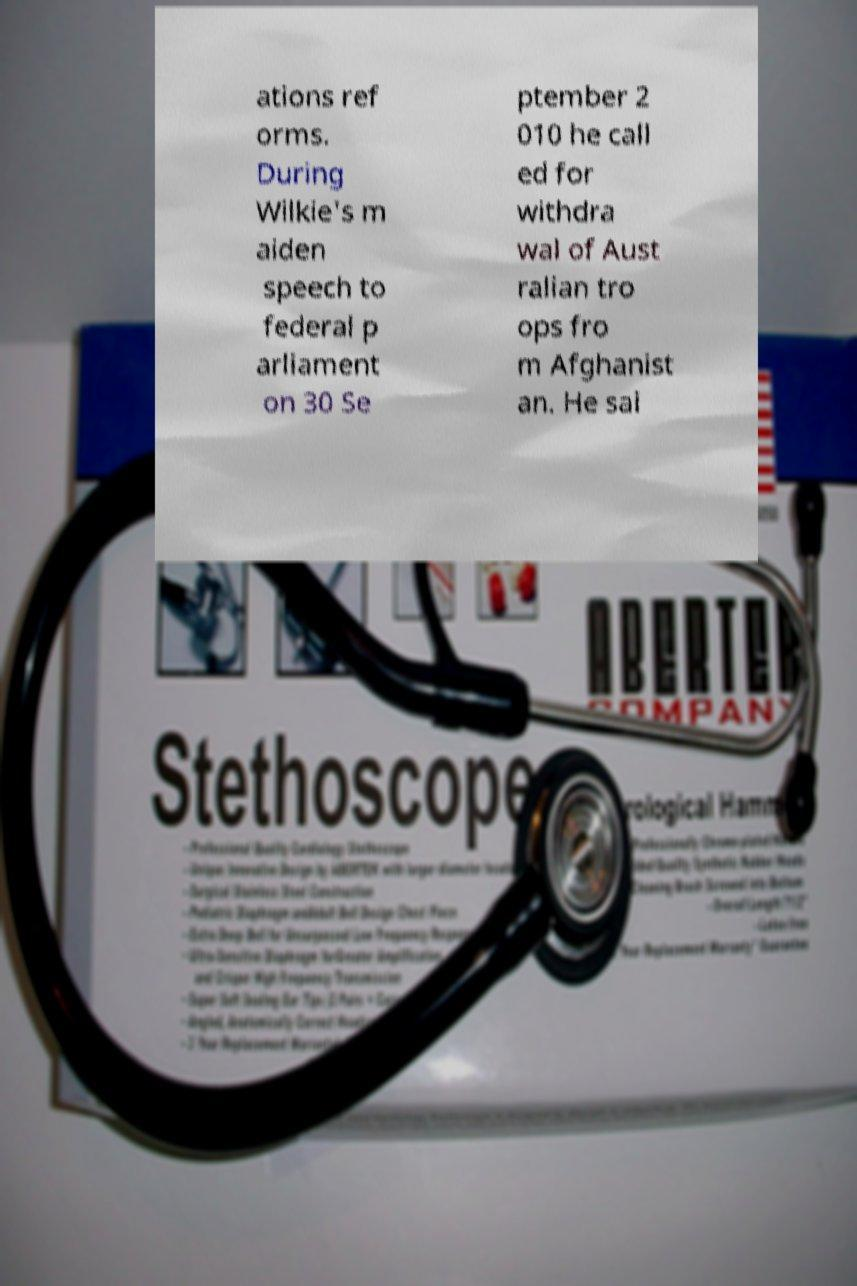Can you read and provide the text displayed in the image?This photo seems to have some interesting text. Can you extract and type it out for me? ations ref orms. During Wilkie's m aiden speech to federal p arliament on 30 Se ptember 2 010 he call ed for withdra wal of Aust ralian tro ops fro m Afghanist an. He sai 